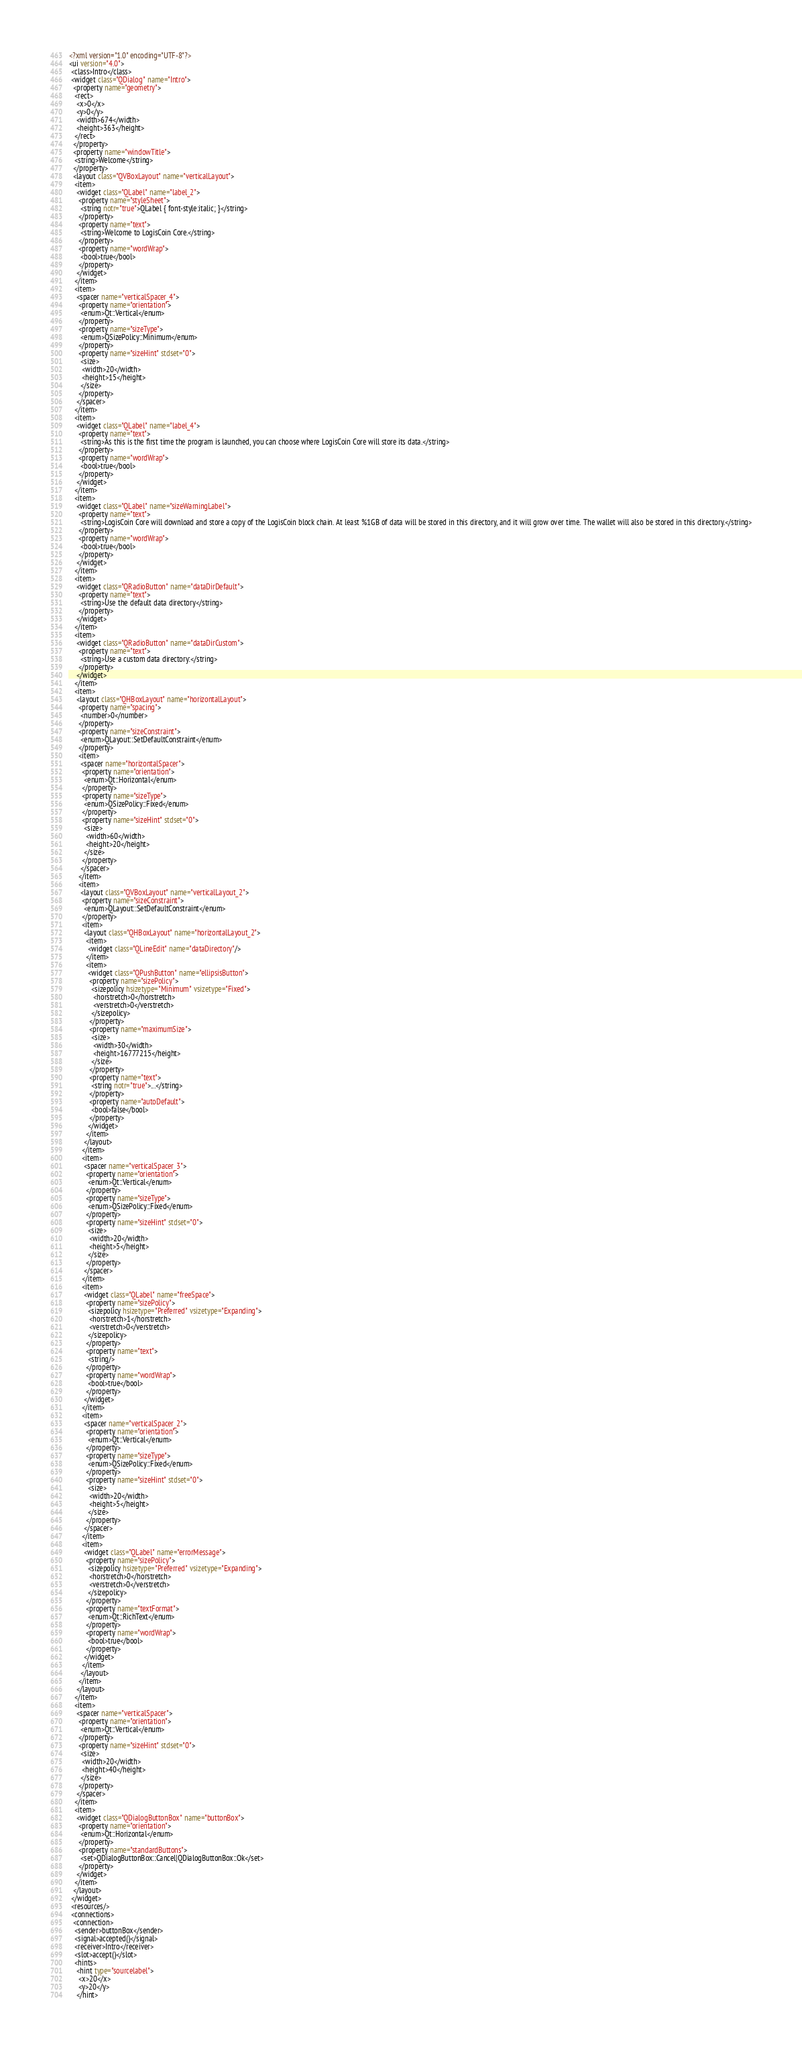Convert code to text. <code><loc_0><loc_0><loc_500><loc_500><_XML_><?xml version="1.0" encoding="UTF-8"?>
<ui version="4.0">
 <class>Intro</class>
 <widget class="QDialog" name="Intro">
  <property name="geometry">
   <rect>
    <x>0</x>
    <y>0</y>
    <width>674</width>
    <height>363</height>
   </rect>
  </property>
  <property name="windowTitle">
   <string>Welcome</string>
  </property>
  <layout class="QVBoxLayout" name="verticalLayout">
   <item>
    <widget class="QLabel" name="label_2">
     <property name="styleSheet">
      <string notr="true">QLabel { font-style:italic; }</string>
     </property>
     <property name="text">
      <string>Welcome to LogisCoin Core.</string>
     </property>
     <property name="wordWrap">
      <bool>true</bool>
     </property>
    </widget>
   </item>
   <item>
    <spacer name="verticalSpacer_4">
     <property name="orientation">
      <enum>Qt::Vertical</enum>
     </property>
     <property name="sizeType">
      <enum>QSizePolicy::Minimum</enum>
     </property>
     <property name="sizeHint" stdset="0">
      <size>
       <width>20</width>
       <height>15</height>
      </size>
     </property>
    </spacer>
   </item>
   <item>
    <widget class="QLabel" name="label_4">
     <property name="text">
      <string>As this is the first time the program is launched, you can choose where LogisCoin Core will store its data.</string>
     </property>
     <property name="wordWrap">
      <bool>true</bool>
     </property>
    </widget>
   </item>
   <item>
    <widget class="QLabel" name="sizeWarningLabel">
     <property name="text">
      <string>LogisCoin Core will download and store a copy of the LogisCoin block chain. At least %1GB of data will be stored in this directory, and it will grow over time. The wallet will also be stored in this directory.</string>
     </property>
     <property name="wordWrap">
      <bool>true</bool>
     </property>
    </widget>
   </item>
   <item>
    <widget class="QRadioButton" name="dataDirDefault">
     <property name="text">
      <string>Use the default data directory</string>
     </property>
    </widget>
   </item>
   <item>
    <widget class="QRadioButton" name="dataDirCustom">
     <property name="text">
      <string>Use a custom data directory:</string>
     </property>
    </widget>
   </item>
   <item>
    <layout class="QHBoxLayout" name="horizontalLayout">
     <property name="spacing">
      <number>0</number>
     </property>
     <property name="sizeConstraint">
      <enum>QLayout::SetDefaultConstraint</enum>
     </property>
     <item>
      <spacer name="horizontalSpacer">
       <property name="orientation">
        <enum>Qt::Horizontal</enum>
       </property>
       <property name="sizeType">
        <enum>QSizePolicy::Fixed</enum>
       </property>
       <property name="sizeHint" stdset="0">
        <size>
         <width>60</width>
         <height>20</height>
        </size>
       </property>
      </spacer>
     </item>
     <item>
      <layout class="QVBoxLayout" name="verticalLayout_2">
       <property name="sizeConstraint">
        <enum>QLayout::SetDefaultConstraint</enum>
       </property>
       <item>
        <layout class="QHBoxLayout" name="horizontalLayout_2">
         <item>
          <widget class="QLineEdit" name="dataDirectory"/>
         </item>
         <item>
          <widget class="QPushButton" name="ellipsisButton">
           <property name="sizePolicy">
            <sizepolicy hsizetype="Minimum" vsizetype="Fixed">
             <horstretch>0</horstretch>
             <verstretch>0</verstretch>
            </sizepolicy>
           </property>
           <property name="maximumSize">
            <size>
             <width>30</width>
             <height>16777215</height>
            </size>
           </property>
           <property name="text">
            <string notr="true">...</string>
           </property>
           <property name="autoDefault">
            <bool>false</bool>
           </property>
          </widget>
         </item>
        </layout>
       </item>
       <item>
        <spacer name="verticalSpacer_3">
         <property name="orientation">
          <enum>Qt::Vertical</enum>
         </property>
         <property name="sizeType">
          <enum>QSizePolicy::Fixed</enum>
         </property>
         <property name="sizeHint" stdset="0">
          <size>
           <width>20</width>
           <height>5</height>
          </size>
         </property>
        </spacer>
       </item>
       <item>
        <widget class="QLabel" name="freeSpace">
         <property name="sizePolicy">
          <sizepolicy hsizetype="Preferred" vsizetype="Expanding">
           <horstretch>1</horstretch>
           <verstretch>0</verstretch>
          </sizepolicy>
         </property>
         <property name="text">
          <string/>
         </property>
         <property name="wordWrap">
          <bool>true</bool>
         </property>
        </widget>
       </item>
       <item>
        <spacer name="verticalSpacer_2">
         <property name="orientation">
          <enum>Qt::Vertical</enum>
         </property>
         <property name="sizeType">
          <enum>QSizePolicy::Fixed</enum>
         </property>
         <property name="sizeHint" stdset="0">
          <size>
           <width>20</width>
           <height>5</height>
          </size>
         </property>
        </spacer>
       </item>
       <item>
        <widget class="QLabel" name="errorMessage">
         <property name="sizePolicy">
          <sizepolicy hsizetype="Preferred" vsizetype="Expanding">
           <horstretch>0</horstretch>
           <verstretch>0</verstretch>
          </sizepolicy>
         </property>
         <property name="textFormat">
          <enum>Qt::RichText</enum>
         </property>
         <property name="wordWrap">
          <bool>true</bool>
         </property>
        </widget>
       </item>
      </layout>
     </item>
    </layout>
   </item>
   <item>
    <spacer name="verticalSpacer">
     <property name="orientation">
      <enum>Qt::Vertical</enum>
     </property>
     <property name="sizeHint" stdset="0">
      <size>
       <width>20</width>
       <height>40</height>
      </size>
     </property>
    </spacer>
   </item>
   <item>
    <widget class="QDialogButtonBox" name="buttonBox">
     <property name="orientation">
      <enum>Qt::Horizontal</enum>
     </property>
     <property name="standardButtons">
      <set>QDialogButtonBox::Cancel|QDialogButtonBox::Ok</set>
     </property>
    </widget>
   </item>
  </layout>
 </widget>
 <resources/>
 <connections>
  <connection>
   <sender>buttonBox</sender>
   <signal>accepted()</signal>
   <receiver>Intro</receiver>
   <slot>accept()</slot>
   <hints>
    <hint type="sourcelabel">
     <x>20</x>
     <y>20</y>
    </hint></code> 